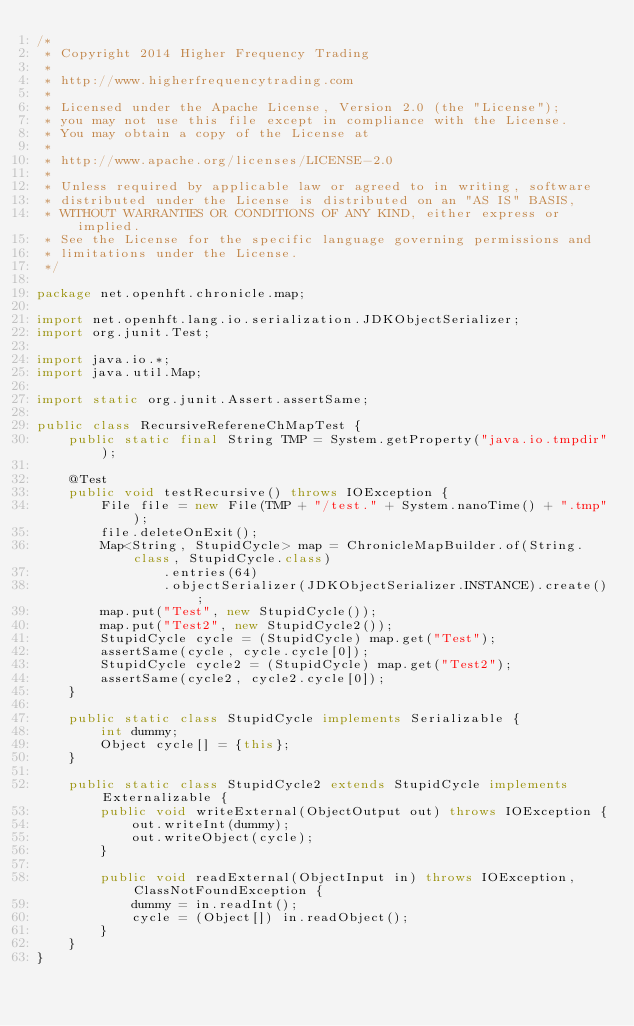Convert code to text. <code><loc_0><loc_0><loc_500><loc_500><_Java_>/*
 * Copyright 2014 Higher Frequency Trading
 *
 * http://www.higherfrequencytrading.com
 *
 * Licensed under the Apache License, Version 2.0 (the "License");
 * you may not use this file except in compliance with the License.
 * You may obtain a copy of the License at
 *
 * http://www.apache.org/licenses/LICENSE-2.0
 *
 * Unless required by applicable law or agreed to in writing, software
 * distributed under the License is distributed on an "AS IS" BASIS,
 * WITHOUT WARRANTIES OR CONDITIONS OF ANY KIND, either express or implied.
 * See the License for the specific language governing permissions and
 * limitations under the License.
 */

package net.openhft.chronicle.map;

import net.openhft.lang.io.serialization.JDKObjectSerializer;
import org.junit.Test;

import java.io.*;
import java.util.Map;

import static org.junit.Assert.assertSame;

public class RecursiveRefereneChMapTest {
    public static final String TMP = System.getProperty("java.io.tmpdir");

    @Test
    public void testRecursive() throws IOException {
        File file = new File(TMP + "/test." + System.nanoTime() + ".tmp");
        file.deleteOnExit();
        Map<String, StupidCycle> map = ChronicleMapBuilder.of(String.class, StupidCycle.class)
                .entries(64)
                .objectSerializer(JDKObjectSerializer.INSTANCE).create();
        map.put("Test", new StupidCycle());
        map.put("Test2", new StupidCycle2());
        StupidCycle cycle = (StupidCycle) map.get("Test");
        assertSame(cycle, cycle.cycle[0]);
        StupidCycle cycle2 = (StupidCycle) map.get("Test2");
        assertSame(cycle2, cycle2.cycle[0]);
    }

    public static class StupidCycle implements Serializable {
        int dummy;
        Object cycle[] = {this};
    }

    public static class StupidCycle2 extends StupidCycle implements Externalizable {
        public void writeExternal(ObjectOutput out) throws IOException {
            out.writeInt(dummy);
            out.writeObject(cycle);
        }

        public void readExternal(ObjectInput in) throws IOException, ClassNotFoundException {
            dummy = in.readInt();
            cycle = (Object[]) in.readObject();
        }
    }
}
</code> 